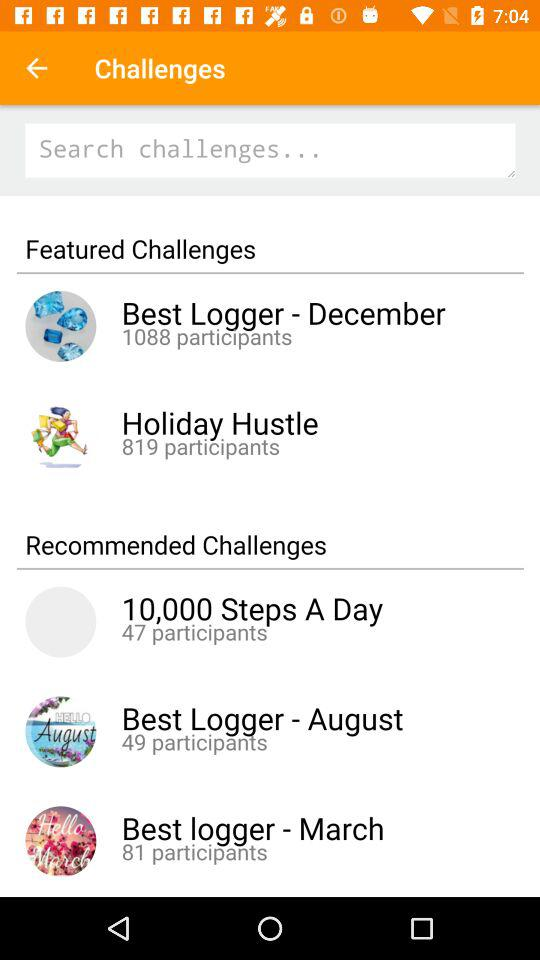How many participants are there in 10,000 steps a day? There are 47 participants. 